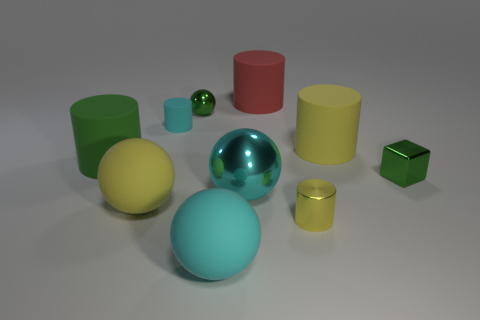Subtract all purple cylinders. Subtract all red spheres. How many cylinders are left? 5 Subtract all blocks. How many objects are left? 9 Add 3 metal blocks. How many metal blocks are left? 4 Add 5 cyan rubber cylinders. How many cyan rubber cylinders exist? 6 Subtract 1 green balls. How many objects are left? 9 Subtract all yellow things. Subtract all big red things. How many objects are left? 6 